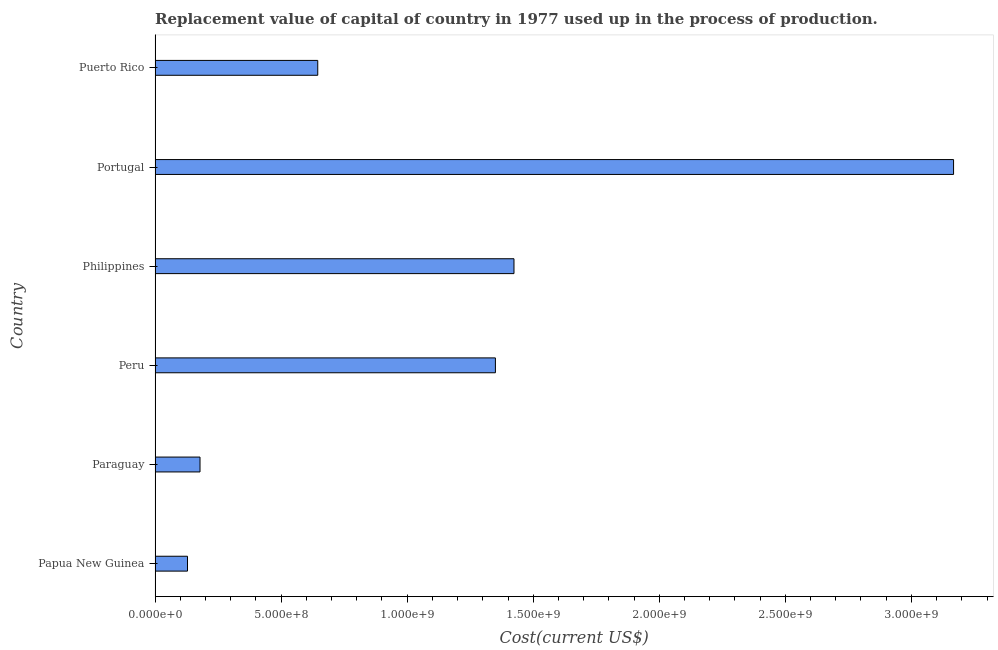Does the graph contain any zero values?
Provide a succinct answer. No. What is the title of the graph?
Your answer should be very brief. Replacement value of capital of country in 1977 used up in the process of production. What is the label or title of the X-axis?
Keep it short and to the point. Cost(current US$). What is the label or title of the Y-axis?
Offer a very short reply. Country. What is the consumption of fixed capital in Philippines?
Offer a terse response. 1.42e+09. Across all countries, what is the maximum consumption of fixed capital?
Provide a short and direct response. 3.17e+09. Across all countries, what is the minimum consumption of fixed capital?
Keep it short and to the point. 1.29e+08. In which country was the consumption of fixed capital minimum?
Offer a very short reply. Papua New Guinea. What is the sum of the consumption of fixed capital?
Provide a short and direct response. 6.89e+09. What is the difference between the consumption of fixed capital in Paraguay and Portugal?
Give a very brief answer. -2.99e+09. What is the average consumption of fixed capital per country?
Provide a short and direct response. 1.15e+09. What is the median consumption of fixed capital?
Give a very brief answer. 9.98e+08. In how many countries, is the consumption of fixed capital greater than 2200000000 US$?
Provide a succinct answer. 1. What is the ratio of the consumption of fixed capital in Philippines to that in Portugal?
Offer a terse response. 0.45. What is the difference between the highest and the second highest consumption of fixed capital?
Provide a succinct answer. 1.74e+09. Is the sum of the consumption of fixed capital in Papua New Guinea and Paraguay greater than the maximum consumption of fixed capital across all countries?
Your response must be concise. No. What is the difference between the highest and the lowest consumption of fixed capital?
Your response must be concise. 3.04e+09. In how many countries, is the consumption of fixed capital greater than the average consumption of fixed capital taken over all countries?
Provide a succinct answer. 3. How many countries are there in the graph?
Keep it short and to the point. 6. Are the values on the major ticks of X-axis written in scientific E-notation?
Keep it short and to the point. Yes. What is the Cost(current US$) of Papua New Guinea?
Provide a succinct answer. 1.29e+08. What is the Cost(current US$) in Paraguay?
Your answer should be compact. 1.78e+08. What is the Cost(current US$) of Peru?
Provide a short and direct response. 1.35e+09. What is the Cost(current US$) in Philippines?
Offer a very short reply. 1.42e+09. What is the Cost(current US$) of Portugal?
Provide a short and direct response. 3.17e+09. What is the Cost(current US$) in Puerto Rico?
Offer a terse response. 6.45e+08. What is the difference between the Cost(current US$) in Papua New Guinea and Paraguay?
Offer a very short reply. -4.97e+07. What is the difference between the Cost(current US$) in Papua New Guinea and Peru?
Offer a very short reply. -1.22e+09. What is the difference between the Cost(current US$) in Papua New Guinea and Philippines?
Give a very brief answer. -1.30e+09. What is the difference between the Cost(current US$) in Papua New Guinea and Portugal?
Your answer should be compact. -3.04e+09. What is the difference between the Cost(current US$) in Papua New Guinea and Puerto Rico?
Provide a short and direct response. -5.17e+08. What is the difference between the Cost(current US$) in Paraguay and Peru?
Give a very brief answer. -1.17e+09. What is the difference between the Cost(current US$) in Paraguay and Philippines?
Ensure brevity in your answer.  -1.25e+09. What is the difference between the Cost(current US$) in Paraguay and Portugal?
Your answer should be compact. -2.99e+09. What is the difference between the Cost(current US$) in Paraguay and Puerto Rico?
Your answer should be very brief. -4.67e+08. What is the difference between the Cost(current US$) in Peru and Philippines?
Ensure brevity in your answer.  -7.37e+07. What is the difference between the Cost(current US$) in Peru and Portugal?
Ensure brevity in your answer.  -1.82e+09. What is the difference between the Cost(current US$) in Peru and Puerto Rico?
Your response must be concise. 7.05e+08. What is the difference between the Cost(current US$) in Philippines and Portugal?
Make the answer very short. -1.74e+09. What is the difference between the Cost(current US$) in Philippines and Puerto Rico?
Give a very brief answer. 7.78e+08. What is the difference between the Cost(current US$) in Portugal and Puerto Rico?
Provide a succinct answer. 2.52e+09. What is the ratio of the Cost(current US$) in Papua New Guinea to that in Paraguay?
Offer a very short reply. 0.72. What is the ratio of the Cost(current US$) in Papua New Guinea to that in Peru?
Provide a succinct answer. 0.1. What is the ratio of the Cost(current US$) in Papua New Guinea to that in Philippines?
Provide a succinct answer. 0.09. What is the ratio of the Cost(current US$) in Papua New Guinea to that in Portugal?
Ensure brevity in your answer.  0.04. What is the ratio of the Cost(current US$) in Papua New Guinea to that in Puerto Rico?
Give a very brief answer. 0.2. What is the ratio of the Cost(current US$) in Paraguay to that in Peru?
Your answer should be compact. 0.13. What is the ratio of the Cost(current US$) in Paraguay to that in Philippines?
Offer a very short reply. 0.12. What is the ratio of the Cost(current US$) in Paraguay to that in Portugal?
Provide a short and direct response. 0.06. What is the ratio of the Cost(current US$) in Paraguay to that in Puerto Rico?
Ensure brevity in your answer.  0.28. What is the ratio of the Cost(current US$) in Peru to that in Philippines?
Make the answer very short. 0.95. What is the ratio of the Cost(current US$) in Peru to that in Portugal?
Keep it short and to the point. 0.43. What is the ratio of the Cost(current US$) in Peru to that in Puerto Rico?
Keep it short and to the point. 2.09. What is the ratio of the Cost(current US$) in Philippines to that in Portugal?
Your answer should be very brief. 0.45. What is the ratio of the Cost(current US$) in Philippines to that in Puerto Rico?
Provide a short and direct response. 2.21. What is the ratio of the Cost(current US$) in Portugal to that in Puerto Rico?
Keep it short and to the point. 4.91. 